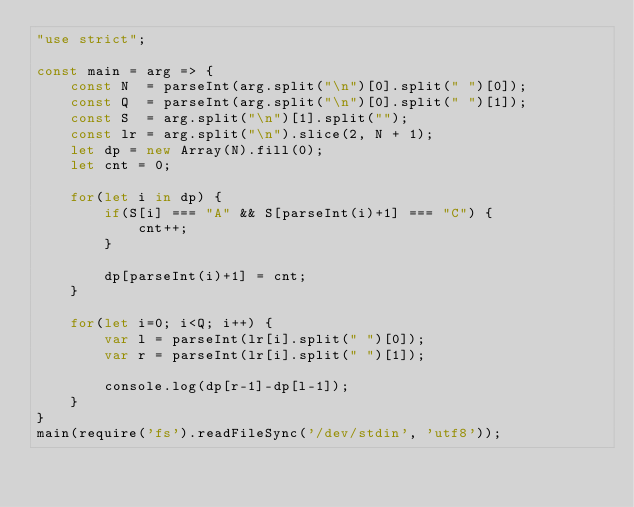Convert code to text. <code><loc_0><loc_0><loc_500><loc_500><_JavaScript_>"use strict";
    
const main = arg => {
    const N  = parseInt(arg.split("\n")[0].split(" ")[0]);
    const Q  = parseInt(arg.split("\n")[0].split(" ")[1]);
    const S  = arg.split("\n")[1].split("");
    const lr = arg.split("\n").slice(2, N + 1);
    let dp = new Array(N).fill(0);
    let cnt = 0;
    
    for(let i in dp) {
        if(S[i] === "A" && S[parseInt(i)+1] === "C") {
            cnt++;
        }
        
        dp[parseInt(i)+1] = cnt;
    }

    for(let i=0; i<Q; i++) {
        var l = parseInt(lr[i].split(" ")[0]);
        var r = parseInt(lr[i].split(" ")[1]);
        
        console.log(dp[r-1]-dp[l-1]);
    }
}
main(require('fs').readFileSync('/dev/stdin', 'utf8'));
</code> 